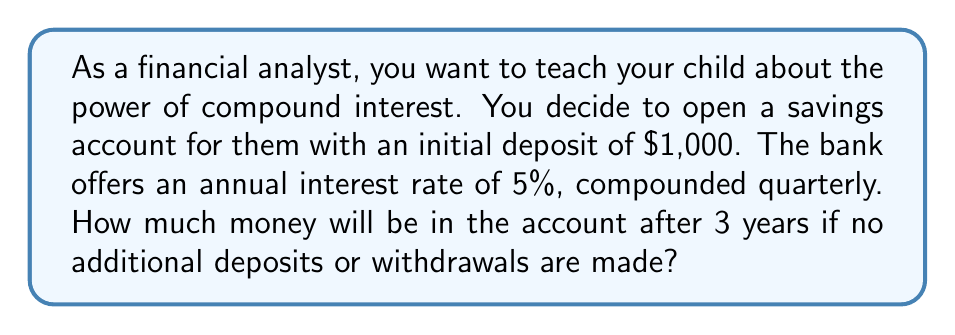Show me your answer to this math problem. Let's break this down step-by-step using the compound interest formula:

$$ A = P(1 + \frac{r}{n})^{nt} $$

Where:
$A$ = Final amount
$P$ = Principal (initial investment)
$r$ = Annual interest rate (as a decimal)
$n$ = Number of times interest is compounded per year
$t$ = Number of years

Given:
$P = \$1,000$
$r = 5\% = 0.05$
$n = 4$ (compounded quarterly)
$t = 3$ years

Let's substitute these values into the formula:

$$ A = 1000(1 + \frac{0.05}{4})^{4 \cdot 3} $$

$$ A = 1000(1 + 0.0125)^{12} $$

$$ A = 1000(1.0125)^{12} $$

Now, let's calculate this:

$$ A = 1000 \cdot 1.160755489 $$

$$ A = 1160.76 $$

Rounding to the nearest cent, we get $1,160.76.
Answer: $1,160.76 